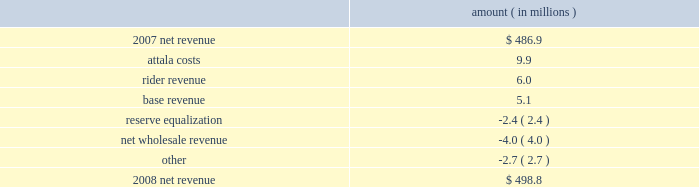Entergy mississippi , inc .
Management's financial discussion and analysis results of operations net income 2008 compared to 2007 net income decreased $ 12.4 million primarily due to higher other operation and maintenance expenses , lower other income , and higher depreciation and amortization expenses , partially offset by higher net revenue .
2007 compared to 2006 net income increased $ 19.8 million primarily due to higher net revenue , lower other operation and maintenance expenses , higher other income , and lower interest expense , partially offset by higher depreciation and amortization expenses .
Net revenue 2008 compared to 2007 net revenue consists of operating revenues net of : 1 ) fuel , fuel-related expenses , and gas purchased for resale , 2 ) purchased power expenses , and 3 ) other regulatory charges .
Following is an analysis of the change in net revenue comparing 2008 to 2007 .
Amount ( in millions ) .
The attala costs variance is primarily due to an increase in the attala power plant costs that are recovered through the power management rider .
The net income effect of this recovery in limited to a portion representing an allowed return on equity with the remainder offset by attala power plant costs in other operation and maintenance expenses , depreciation expenses , and taxes other than income taxes .
The recovery of attala power plant costs is discussed further in "liquidity and capital resources - uses of capital" below .
The rider revenue variance is the result of a storm damage rider that became effective in october 2007 .
The establishment of this rider results in an increase in rider revenue and a corresponding increase in other operation and maintenance expense for the storm reserve with no effect on net income .
The base revenue variance is primarily due to a formula rate plan increase effective july 2007 .
The formula rate plan filing is discussed further in "state and local rate regulation" below .
The reserve equalization variance is primarily due to changes in the entergy system generation mix compared to the same period in 2007. .
What is the percent change in net revenue between 2007 and 2008? 
Computations: ((498.8 - 486.9) / 486.9)
Answer: 0.02444. 